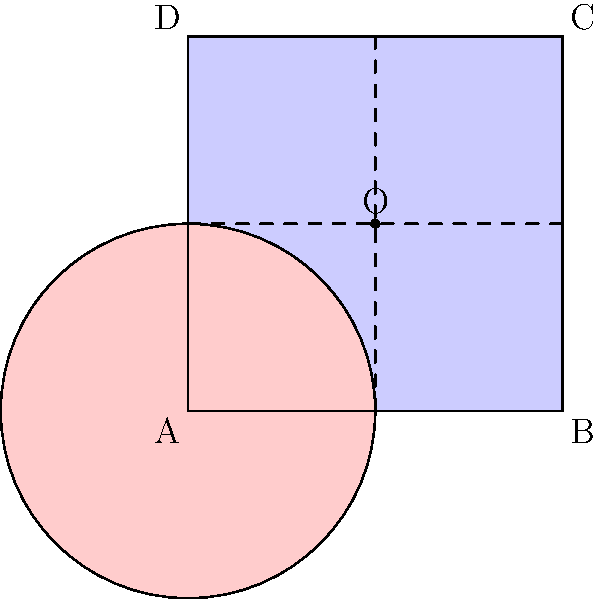In a custody evaluation, you and your ex-spouse need to divide your assets. The square ABCD represents your house (valued at $400,000), and the circle represents a shared investment account (valued at $100,000). If the assets are to be divided equally, what is the value of the assets you should receive, assuming you get the non-overlapping part of the square plus half of the overlapping area? Let's approach this step-by-step:

1) First, we need to calculate the areas of the shapes:
   - Area of the square: $4 \times 4 = 16$ square units
   - Area of the circle: $\pi r^2 = \pi \times 2^2 = 4\pi$ square units

2) The overlapping area is the area of the circle: $4\pi$ square units

3) The non-overlapping area of the square is:
   $16 - 4\pi$ square units

4) You get the non-overlapping part of the square plus half of the overlapping area:
   $(16 - 4\pi) + \frac{1}{2}(4\pi) = 16 - 2\pi$ square units

5) To find the fraction of the total area this represents:
   $\frac{16 - 2\pi}{16 + 4\pi}$

6) The total value of the assets is $\$500,000$

7) Your share: $\$500,000 \times \frac{16 - 2\pi}{16 + 4\pi} \approx \$275,916$
Answer: $275,916 